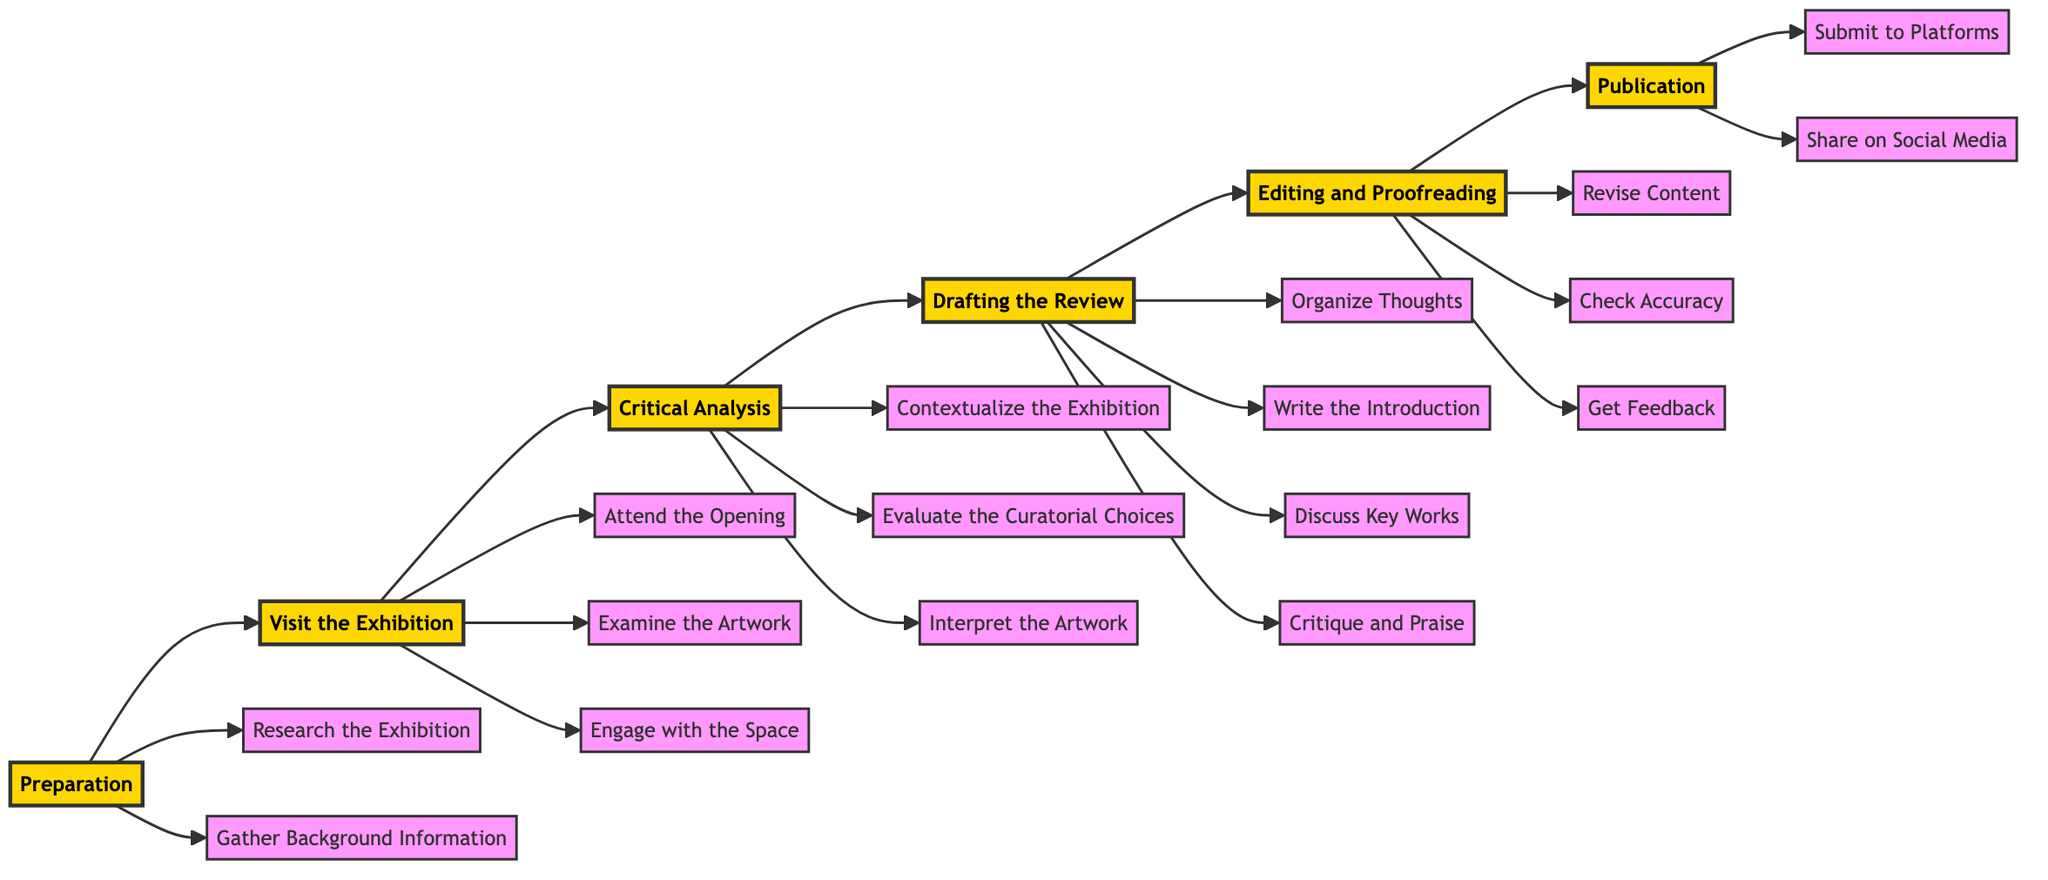What is the first stage in the process? The first stage indicated in the diagram is "Preparation." This is the starting point of the flowchart that outlines the process of writing an art exhibition review.
Answer: Preparation How many tasks are listed under the "Visit the Exhibition" stage? There are three tasks listed under the "Visit the Exhibition" stage: "Attend the Opening," "Examine the Artwork," and "Engage with the Space." Counting these, we see a total of three tasks.
Answer: 3 Which task comes directly after "Research the Exhibition"? The task that follows immediately after "Research the Exhibition" in the flowchart is "Gather Background Information." This indicates a sequential process where tasks are done one after another.
Answer: Gather Background Information What is the last task in the flowchart? The last task shown in the flowchart is "Share on Social Media." This indicates it is the final step after the review has been submitted to platforms.
Answer: Share on Social Media Which stage contains the task "Revise Content"? The task "Revise Content" is contained within the "Editing and Proofreading" stage of the flowchart. This shows it is part of the review refinement process before publication.
Answer: Editing and Proofreading What is the relationship between "Critical Analysis" and "Drafting the Review"? "Critical Analysis" feeds directly into "Drafting the Review" as indicated by a directional arrow. This indicates that after the analysis, the reviewer organizes their thoughts into a draft.
Answer: Directly feeds into How many stages are there in total in the flowchart? There are six distinct stages presented in the flowchart: Preparation, Visit the Exhibition, Critical Analysis, Drafting the Review, Editing and Proofreading, and Publication. Counting these stages gives a total of six.
Answer: 6 Which stage follows "Editing and Proofreading"? "Publication" follows directly after the "Editing and Proofreading" stage in the sequence displayed in the flowchart, indicating it comes last in the process flow.
Answer: Publication What phase involves "Contextualize the Exhibition"? The task "Contextualize the Exhibition" is part of the "Critical Analysis" phase, suggesting that it is a key aspect of reviewing the exhibition in context.
Answer: Critical Analysis 